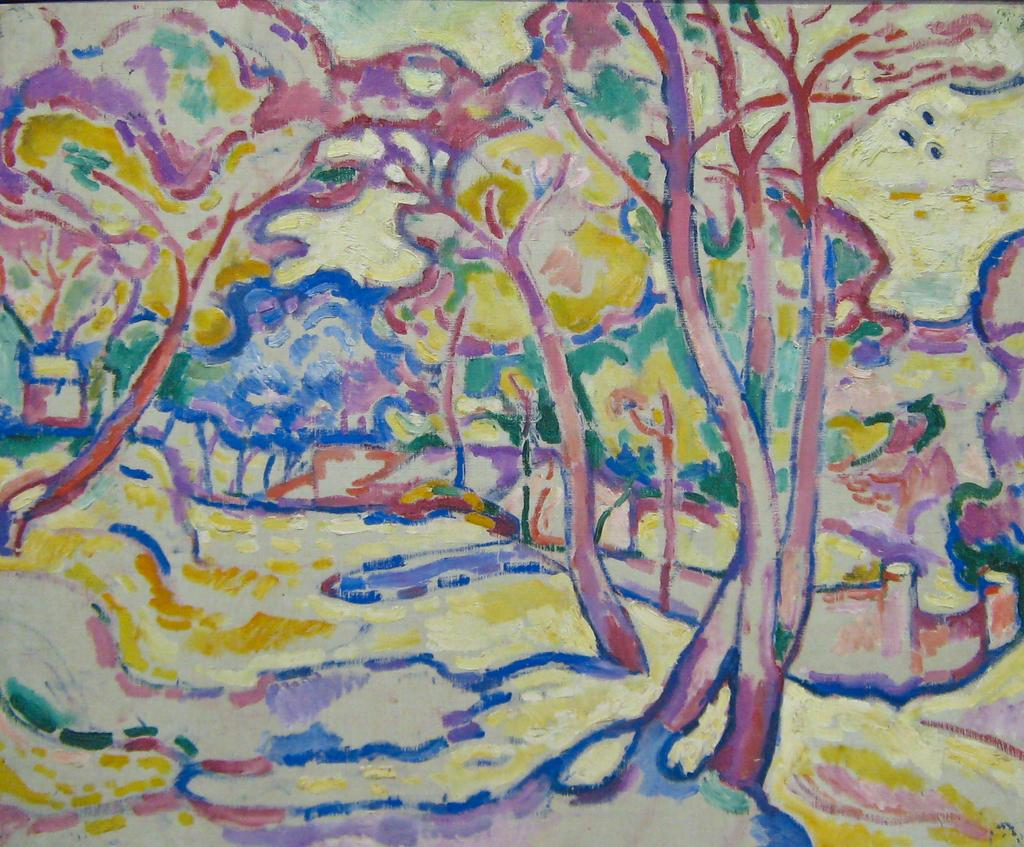What is the main subject of the painting in the image? The main subject of the painting in the image is trees. Can you tell me what the woman is doing with the pig in the painting? There is no woman or pig present in the painting; it features trees as the main subject. 